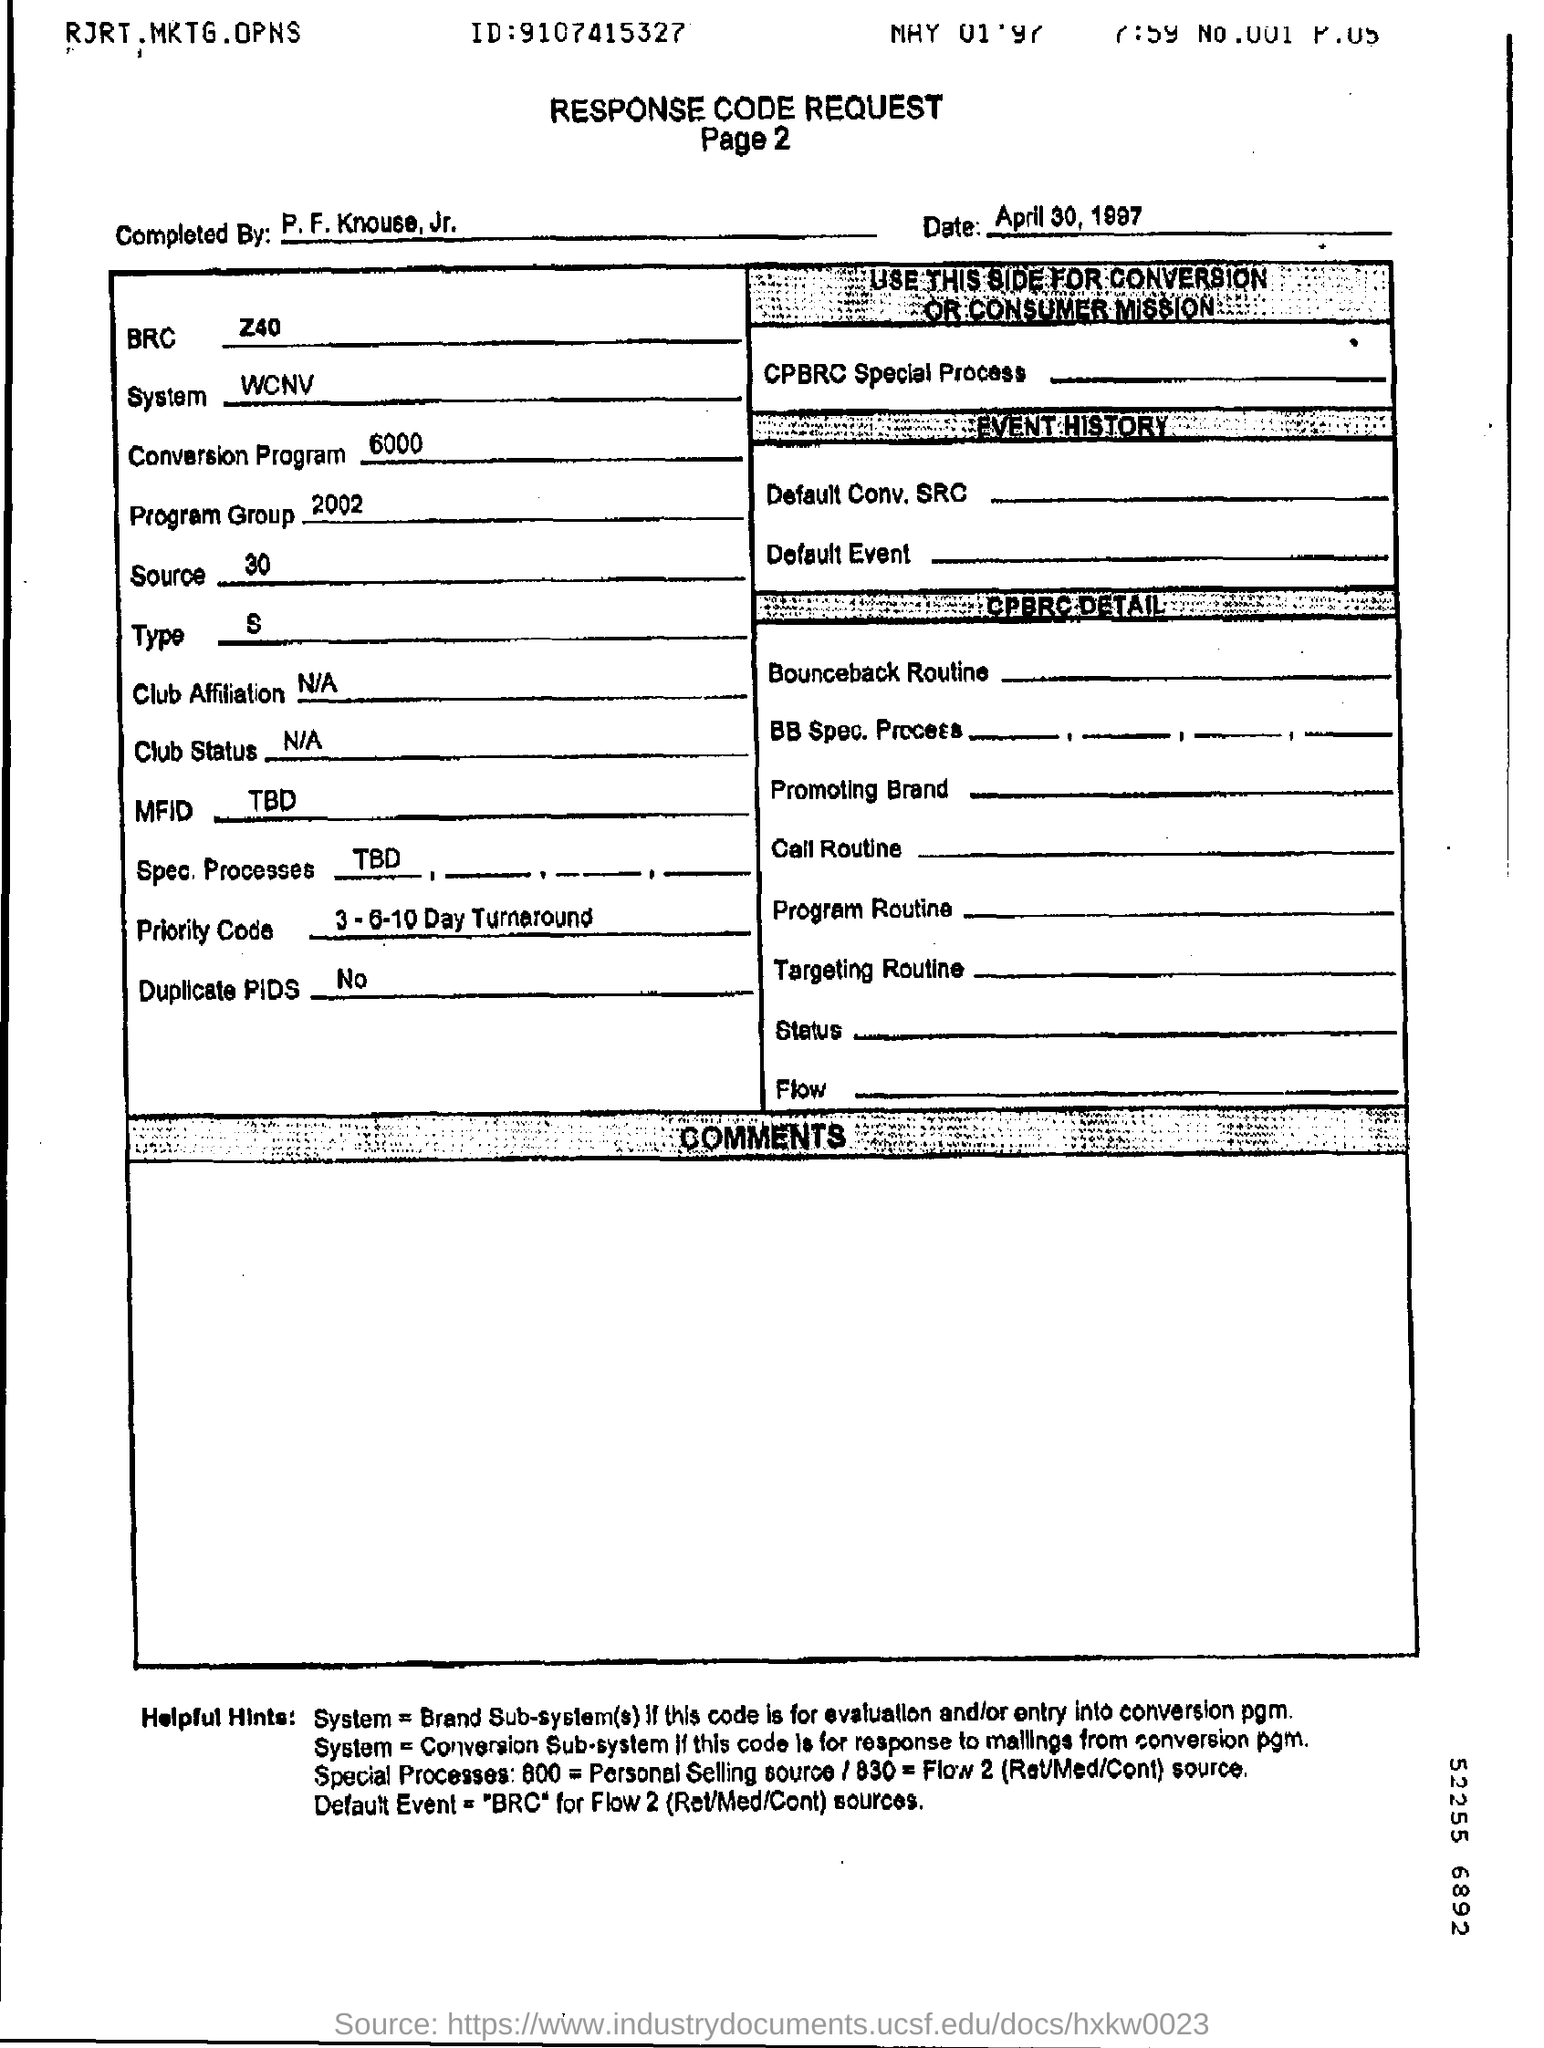What is the heading of the document?
Give a very brief answer. Response Code Request. What is the BRC mentioned?
Offer a very short reply. Z40. 